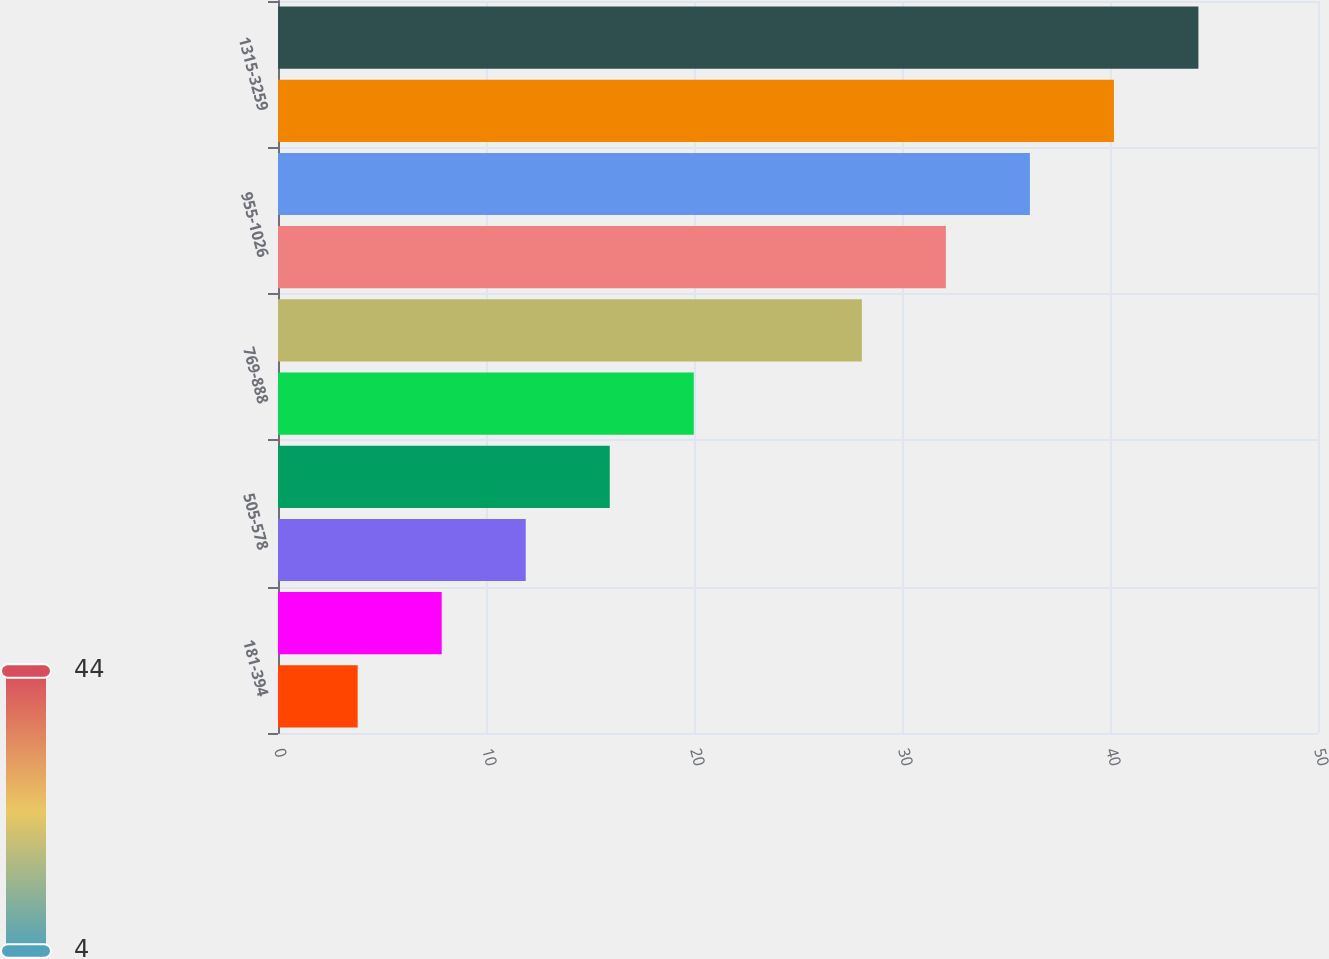Convert chart. <chart><loc_0><loc_0><loc_500><loc_500><bar_chart><fcel>181-394<fcel>400-500<fcel>505-578<fcel>587-768<fcel>769-888<fcel>900-950<fcel>955-1026<fcel>1050-1313<fcel>1315-3259<fcel>4425<nl><fcel>3.83<fcel>7.87<fcel>11.91<fcel>15.95<fcel>19.99<fcel>28.07<fcel>32.11<fcel>36.15<fcel>40.19<fcel>44.25<nl></chart> 